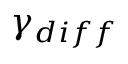Convert formula to latex. <formula><loc_0><loc_0><loc_500><loc_500>\gamma _ { d i f f }</formula> 